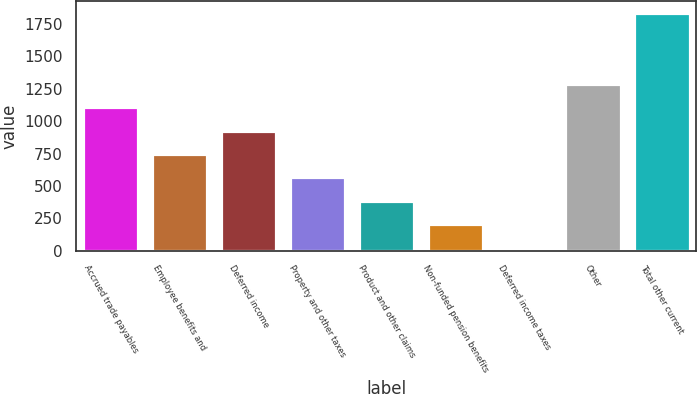Convert chart. <chart><loc_0><loc_0><loc_500><loc_500><bar_chart><fcel>Accrued trade payables<fcel>Employee benefits and<fcel>Deferred income<fcel>Property and other taxes<fcel>Product and other claims<fcel>Non-funded pension benefits<fcel>Deferred income taxes<fcel>Other<fcel>Total other current<nl><fcel>1108.6<fcel>746.4<fcel>927.5<fcel>565.3<fcel>384.2<fcel>203.1<fcel>22<fcel>1289.7<fcel>1833<nl></chart> 